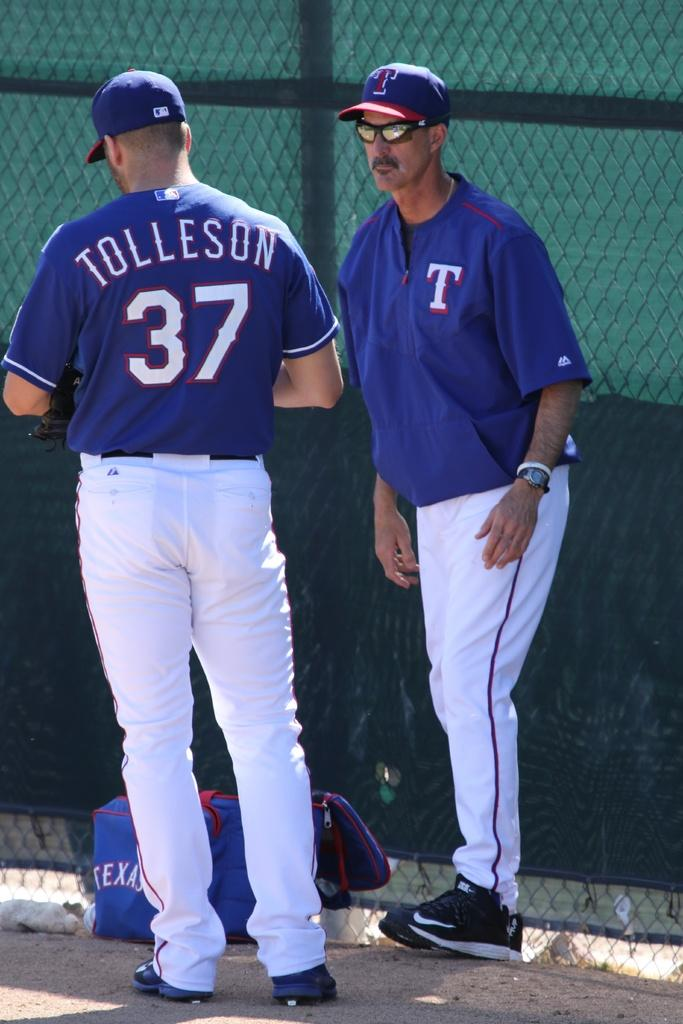<image>
Write a terse but informative summary of the picture. a Texas baseballplayer named Tolleson standing with teammate 